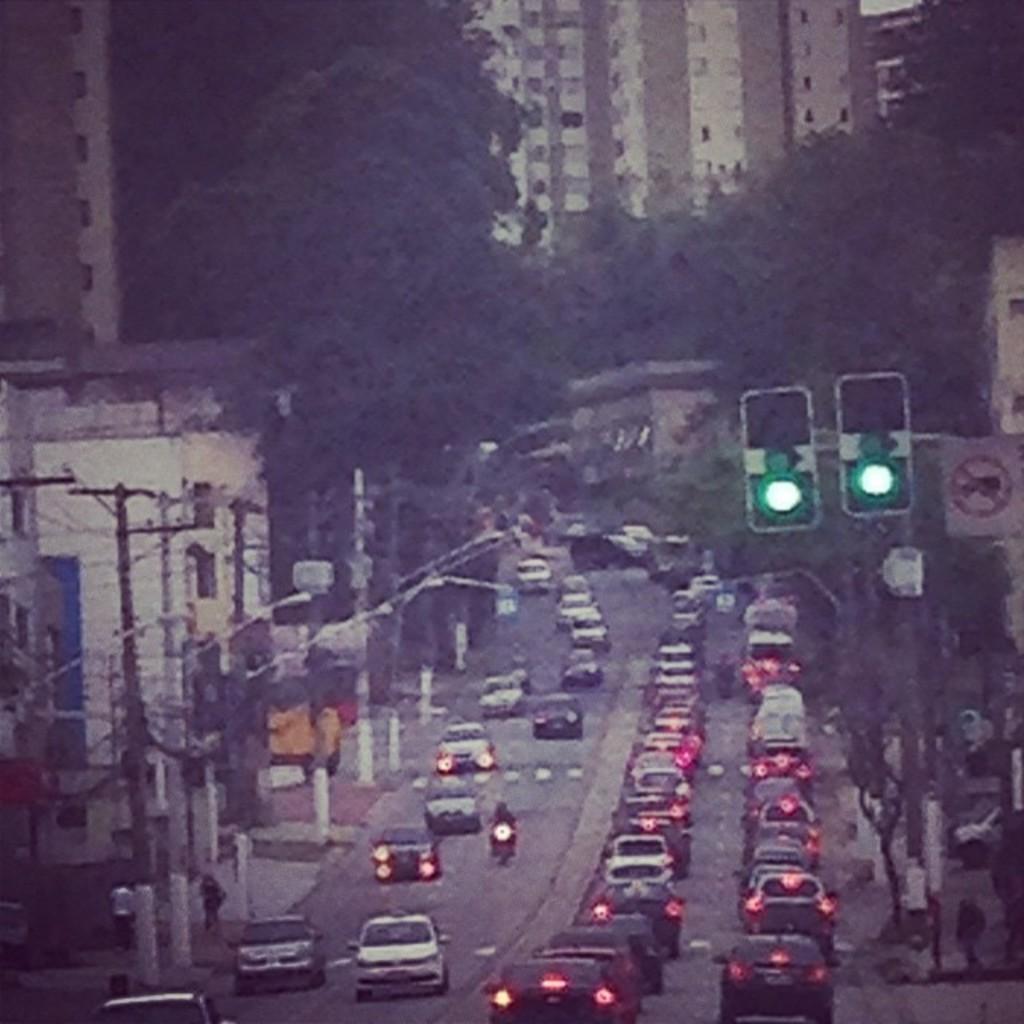How would you summarize this image in a sentence or two? In this image few vehicles are on the road. Few poles are connected with wires. Right side there is a pole having two traffic lights and a board is attached to it. Background there are few trees and buildings. Few persons are walking on the pavement. 